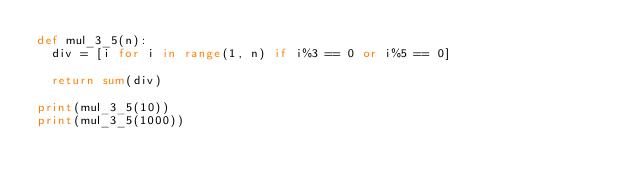<code> <loc_0><loc_0><loc_500><loc_500><_Python_>def mul_3_5(n):
	div = [i for i in range(1, n) if i%3 == 0 or i%5 == 0]
	
	return sum(div)

print(mul_3_5(10))
print(mul_3_5(1000))</code> 